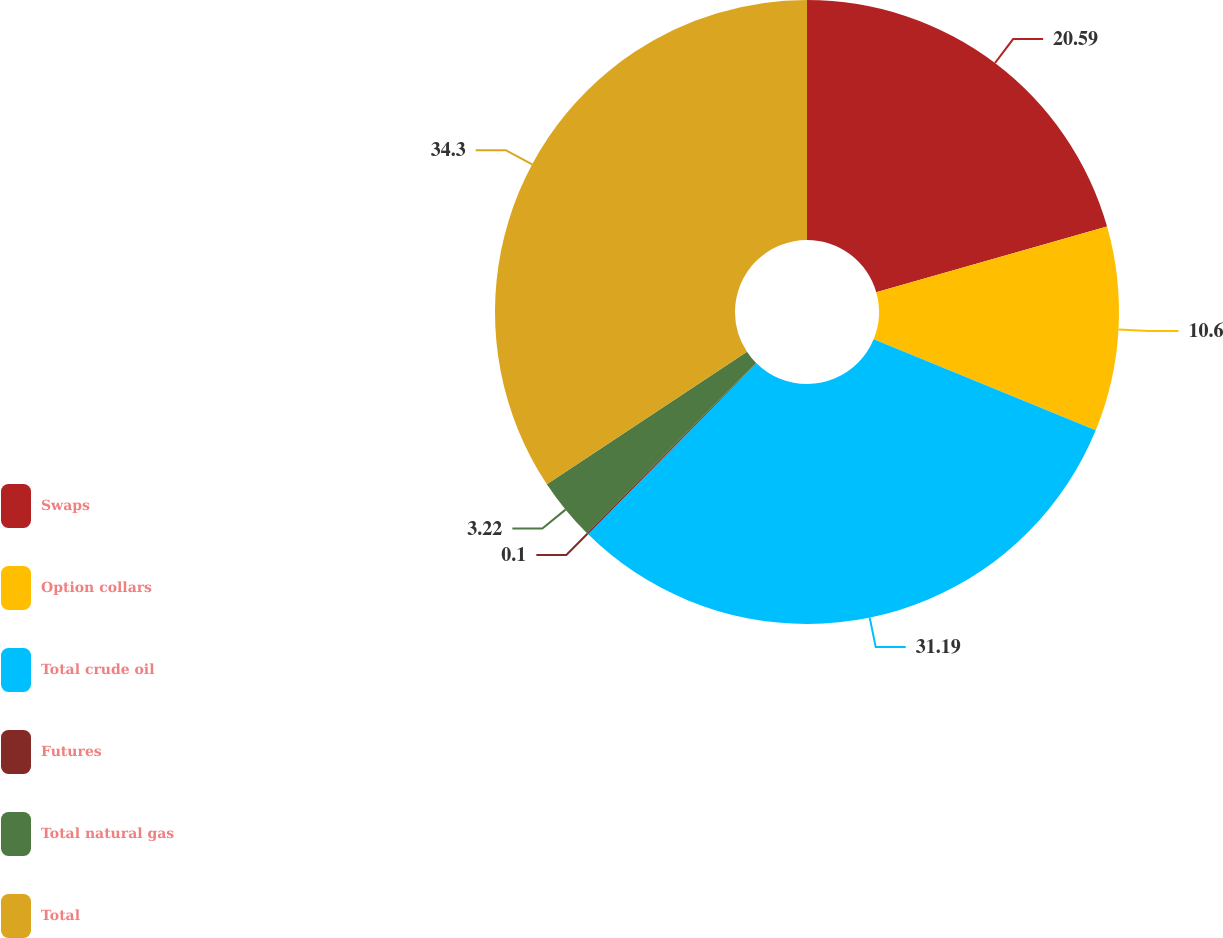<chart> <loc_0><loc_0><loc_500><loc_500><pie_chart><fcel>Swaps<fcel>Option collars<fcel>Total crude oil<fcel>Futures<fcel>Total natural gas<fcel>Total<nl><fcel>20.59%<fcel>10.6%<fcel>31.19%<fcel>0.1%<fcel>3.22%<fcel>34.31%<nl></chart> 